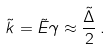Convert formula to latex. <formula><loc_0><loc_0><loc_500><loc_500>\tilde { k } = \tilde { E } { \gamma } \approx \frac { \tilde { \Delta } } { 2 } \, .</formula> 